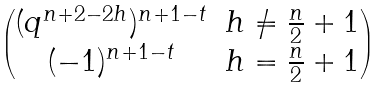<formula> <loc_0><loc_0><loc_500><loc_500>\begin{pmatrix} ( q ^ { n + 2 - 2 h } ) ^ { n + 1 - t } & h \ne \frac { n } { 2 } + 1 \\ ( - 1 ) ^ { n + 1 - t } & h = \frac { n } { 2 } + 1 \end{pmatrix}</formula> 